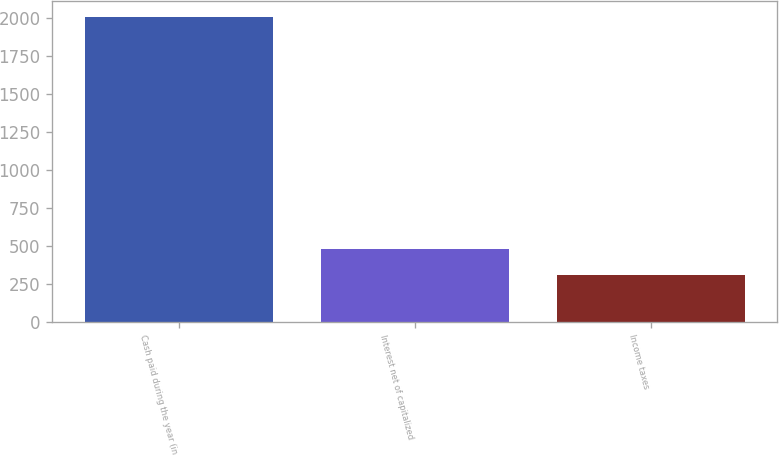<chart> <loc_0><loc_0><loc_500><loc_500><bar_chart><fcel>Cash paid during the year (in<fcel>Interest net of capitalized<fcel>Income taxes<nl><fcel>2011<fcel>476.5<fcel>306<nl></chart> 